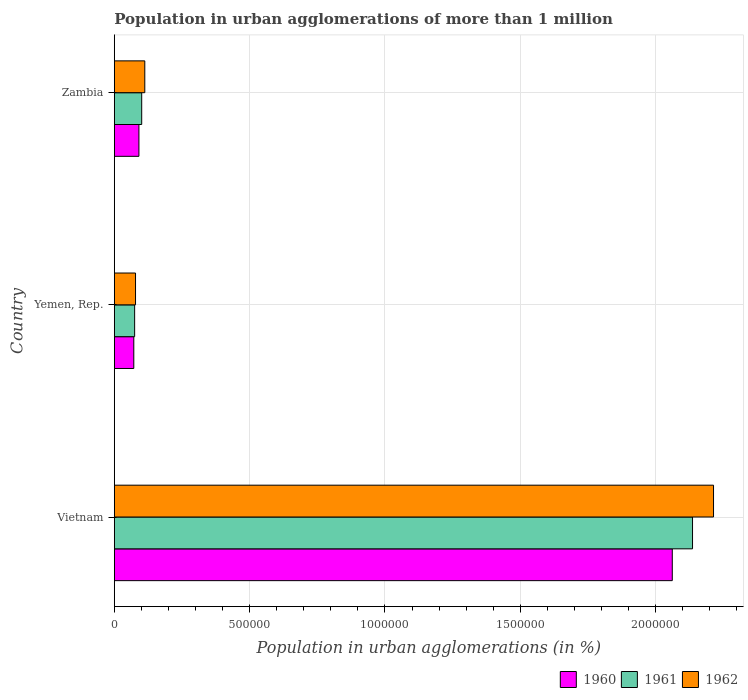How many different coloured bars are there?
Give a very brief answer. 3. Are the number of bars per tick equal to the number of legend labels?
Provide a short and direct response. Yes. Are the number of bars on each tick of the Y-axis equal?
Ensure brevity in your answer.  Yes. How many bars are there on the 2nd tick from the top?
Offer a very short reply. 3. How many bars are there on the 3rd tick from the bottom?
Ensure brevity in your answer.  3. What is the label of the 1st group of bars from the top?
Keep it short and to the point. Zambia. What is the population in urban agglomerations in 1962 in Vietnam?
Your answer should be very brief. 2.21e+06. Across all countries, what is the maximum population in urban agglomerations in 1960?
Your answer should be compact. 2.06e+06. Across all countries, what is the minimum population in urban agglomerations in 1962?
Ensure brevity in your answer.  7.84e+04. In which country was the population in urban agglomerations in 1962 maximum?
Give a very brief answer. Vietnam. In which country was the population in urban agglomerations in 1962 minimum?
Your response must be concise. Yemen, Rep. What is the total population in urban agglomerations in 1961 in the graph?
Offer a very short reply. 2.31e+06. What is the difference between the population in urban agglomerations in 1962 in Vietnam and that in Yemen, Rep.?
Make the answer very short. 2.14e+06. What is the difference between the population in urban agglomerations in 1960 in Yemen, Rep. and the population in urban agglomerations in 1962 in Vietnam?
Provide a succinct answer. -2.14e+06. What is the average population in urban agglomerations in 1961 per country?
Your response must be concise. 7.71e+05. What is the difference between the population in urban agglomerations in 1960 and population in urban agglomerations in 1962 in Zambia?
Offer a very short reply. -2.17e+04. In how many countries, is the population in urban agglomerations in 1962 greater than 800000 %?
Give a very brief answer. 1. What is the ratio of the population in urban agglomerations in 1962 in Vietnam to that in Zambia?
Ensure brevity in your answer.  19.66. Is the population in urban agglomerations in 1961 in Vietnam less than that in Yemen, Rep.?
Ensure brevity in your answer.  No. What is the difference between the highest and the second highest population in urban agglomerations in 1961?
Give a very brief answer. 2.04e+06. What is the difference between the highest and the lowest population in urban agglomerations in 1962?
Make the answer very short. 2.14e+06. In how many countries, is the population in urban agglomerations in 1962 greater than the average population in urban agglomerations in 1962 taken over all countries?
Your response must be concise. 1. What does the 3rd bar from the top in Zambia represents?
Offer a terse response. 1960. How many bars are there?
Your answer should be very brief. 9. Are all the bars in the graph horizontal?
Give a very brief answer. Yes. How many countries are there in the graph?
Keep it short and to the point. 3. Are the values on the major ticks of X-axis written in scientific E-notation?
Ensure brevity in your answer.  No. Does the graph contain any zero values?
Keep it short and to the point. No. Where does the legend appear in the graph?
Offer a terse response. Bottom right. How many legend labels are there?
Make the answer very short. 3. What is the title of the graph?
Offer a terse response. Population in urban agglomerations of more than 1 million. Does "1968" appear as one of the legend labels in the graph?
Make the answer very short. No. What is the label or title of the X-axis?
Your response must be concise. Population in urban agglomerations (in %). What is the label or title of the Y-axis?
Keep it short and to the point. Country. What is the Population in urban agglomerations (in %) in 1960 in Vietnam?
Keep it short and to the point. 2.06e+06. What is the Population in urban agglomerations (in %) of 1961 in Vietnam?
Provide a succinct answer. 2.14e+06. What is the Population in urban agglomerations (in %) in 1962 in Vietnam?
Your answer should be very brief. 2.21e+06. What is the Population in urban agglomerations (in %) in 1960 in Yemen, Rep.?
Make the answer very short. 7.20e+04. What is the Population in urban agglomerations (in %) in 1961 in Yemen, Rep.?
Provide a short and direct response. 7.52e+04. What is the Population in urban agglomerations (in %) in 1962 in Yemen, Rep.?
Provide a succinct answer. 7.84e+04. What is the Population in urban agglomerations (in %) in 1960 in Zambia?
Your answer should be very brief. 9.09e+04. What is the Population in urban agglomerations (in %) of 1961 in Zambia?
Keep it short and to the point. 1.01e+05. What is the Population in urban agglomerations (in %) in 1962 in Zambia?
Offer a very short reply. 1.13e+05. Across all countries, what is the maximum Population in urban agglomerations (in %) of 1960?
Your answer should be very brief. 2.06e+06. Across all countries, what is the maximum Population in urban agglomerations (in %) of 1961?
Provide a short and direct response. 2.14e+06. Across all countries, what is the maximum Population in urban agglomerations (in %) in 1962?
Offer a terse response. 2.21e+06. Across all countries, what is the minimum Population in urban agglomerations (in %) of 1960?
Offer a very short reply. 7.20e+04. Across all countries, what is the minimum Population in urban agglomerations (in %) of 1961?
Give a very brief answer. 7.52e+04. Across all countries, what is the minimum Population in urban agglomerations (in %) of 1962?
Your response must be concise. 7.84e+04. What is the total Population in urban agglomerations (in %) in 1960 in the graph?
Make the answer very short. 2.22e+06. What is the total Population in urban agglomerations (in %) of 1961 in the graph?
Provide a short and direct response. 2.31e+06. What is the total Population in urban agglomerations (in %) in 1962 in the graph?
Your answer should be very brief. 2.41e+06. What is the difference between the Population in urban agglomerations (in %) in 1960 in Vietnam and that in Yemen, Rep.?
Offer a terse response. 1.99e+06. What is the difference between the Population in urban agglomerations (in %) of 1961 in Vietnam and that in Yemen, Rep.?
Your answer should be compact. 2.06e+06. What is the difference between the Population in urban agglomerations (in %) in 1962 in Vietnam and that in Yemen, Rep.?
Your answer should be compact. 2.14e+06. What is the difference between the Population in urban agglomerations (in %) in 1960 in Vietnam and that in Zambia?
Your answer should be compact. 1.97e+06. What is the difference between the Population in urban agglomerations (in %) of 1961 in Vietnam and that in Zambia?
Your answer should be very brief. 2.04e+06. What is the difference between the Population in urban agglomerations (in %) of 1962 in Vietnam and that in Zambia?
Offer a terse response. 2.10e+06. What is the difference between the Population in urban agglomerations (in %) of 1960 in Yemen, Rep. and that in Zambia?
Offer a very short reply. -1.89e+04. What is the difference between the Population in urban agglomerations (in %) of 1961 in Yemen, Rep. and that in Zambia?
Your answer should be compact. -2.61e+04. What is the difference between the Population in urban agglomerations (in %) of 1962 in Yemen, Rep. and that in Zambia?
Provide a succinct answer. -3.42e+04. What is the difference between the Population in urban agglomerations (in %) in 1960 in Vietnam and the Population in urban agglomerations (in %) in 1961 in Yemen, Rep.?
Provide a succinct answer. 1.99e+06. What is the difference between the Population in urban agglomerations (in %) in 1960 in Vietnam and the Population in urban agglomerations (in %) in 1962 in Yemen, Rep.?
Offer a very short reply. 1.98e+06. What is the difference between the Population in urban agglomerations (in %) of 1961 in Vietnam and the Population in urban agglomerations (in %) of 1962 in Yemen, Rep.?
Offer a very short reply. 2.06e+06. What is the difference between the Population in urban agglomerations (in %) in 1960 in Vietnam and the Population in urban agglomerations (in %) in 1961 in Zambia?
Provide a short and direct response. 1.96e+06. What is the difference between the Population in urban agglomerations (in %) of 1960 in Vietnam and the Population in urban agglomerations (in %) of 1962 in Zambia?
Provide a succinct answer. 1.95e+06. What is the difference between the Population in urban agglomerations (in %) of 1961 in Vietnam and the Population in urban agglomerations (in %) of 1962 in Zambia?
Give a very brief answer. 2.02e+06. What is the difference between the Population in urban agglomerations (in %) in 1960 in Yemen, Rep. and the Population in urban agglomerations (in %) in 1961 in Zambia?
Provide a short and direct response. -2.92e+04. What is the difference between the Population in urban agglomerations (in %) of 1960 in Yemen, Rep. and the Population in urban agglomerations (in %) of 1962 in Zambia?
Ensure brevity in your answer.  -4.06e+04. What is the difference between the Population in urban agglomerations (in %) of 1961 in Yemen, Rep. and the Population in urban agglomerations (in %) of 1962 in Zambia?
Provide a short and direct response. -3.75e+04. What is the average Population in urban agglomerations (in %) of 1960 per country?
Provide a succinct answer. 7.42e+05. What is the average Population in urban agglomerations (in %) of 1961 per country?
Keep it short and to the point. 7.71e+05. What is the average Population in urban agglomerations (in %) in 1962 per country?
Your response must be concise. 8.02e+05. What is the difference between the Population in urban agglomerations (in %) in 1960 and Population in urban agglomerations (in %) in 1961 in Vietnam?
Ensure brevity in your answer.  -7.48e+04. What is the difference between the Population in urban agglomerations (in %) in 1960 and Population in urban agglomerations (in %) in 1962 in Vietnam?
Keep it short and to the point. -1.52e+05. What is the difference between the Population in urban agglomerations (in %) in 1961 and Population in urban agglomerations (in %) in 1962 in Vietnam?
Your answer should be compact. -7.76e+04. What is the difference between the Population in urban agglomerations (in %) in 1960 and Population in urban agglomerations (in %) in 1961 in Yemen, Rep.?
Provide a short and direct response. -3151. What is the difference between the Population in urban agglomerations (in %) in 1960 and Population in urban agglomerations (in %) in 1962 in Yemen, Rep.?
Your response must be concise. -6444. What is the difference between the Population in urban agglomerations (in %) in 1961 and Population in urban agglomerations (in %) in 1962 in Yemen, Rep.?
Offer a terse response. -3293. What is the difference between the Population in urban agglomerations (in %) in 1960 and Population in urban agglomerations (in %) in 1961 in Zambia?
Make the answer very short. -1.03e+04. What is the difference between the Population in urban agglomerations (in %) in 1960 and Population in urban agglomerations (in %) in 1962 in Zambia?
Offer a terse response. -2.17e+04. What is the difference between the Population in urban agglomerations (in %) in 1961 and Population in urban agglomerations (in %) in 1962 in Zambia?
Ensure brevity in your answer.  -1.14e+04. What is the ratio of the Population in urban agglomerations (in %) of 1960 in Vietnam to that in Yemen, Rep.?
Your answer should be very brief. 28.64. What is the ratio of the Population in urban agglomerations (in %) in 1961 in Vietnam to that in Yemen, Rep.?
Your response must be concise. 28.43. What is the ratio of the Population in urban agglomerations (in %) in 1962 in Vietnam to that in Yemen, Rep.?
Give a very brief answer. 28.23. What is the ratio of the Population in urban agglomerations (in %) of 1960 in Vietnam to that in Zambia?
Ensure brevity in your answer.  22.67. What is the ratio of the Population in urban agglomerations (in %) in 1961 in Vietnam to that in Zambia?
Provide a succinct answer. 21.11. What is the ratio of the Population in urban agglomerations (in %) of 1962 in Vietnam to that in Zambia?
Keep it short and to the point. 19.66. What is the ratio of the Population in urban agglomerations (in %) in 1960 in Yemen, Rep. to that in Zambia?
Offer a terse response. 0.79. What is the ratio of the Population in urban agglomerations (in %) of 1961 in Yemen, Rep. to that in Zambia?
Ensure brevity in your answer.  0.74. What is the ratio of the Population in urban agglomerations (in %) of 1962 in Yemen, Rep. to that in Zambia?
Provide a short and direct response. 0.7. What is the difference between the highest and the second highest Population in urban agglomerations (in %) in 1960?
Keep it short and to the point. 1.97e+06. What is the difference between the highest and the second highest Population in urban agglomerations (in %) of 1961?
Your answer should be compact. 2.04e+06. What is the difference between the highest and the second highest Population in urban agglomerations (in %) in 1962?
Keep it short and to the point. 2.10e+06. What is the difference between the highest and the lowest Population in urban agglomerations (in %) in 1960?
Provide a succinct answer. 1.99e+06. What is the difference between the highest and the lowest Population in urban agglomerations (in %) in 1961?
Give a very brief answer. 2.06e+06. What is the difference between the highest and the lowest Population in urban agglomerations (in %) of 1962?
Your answer should be very brief. 2.14e+06. 